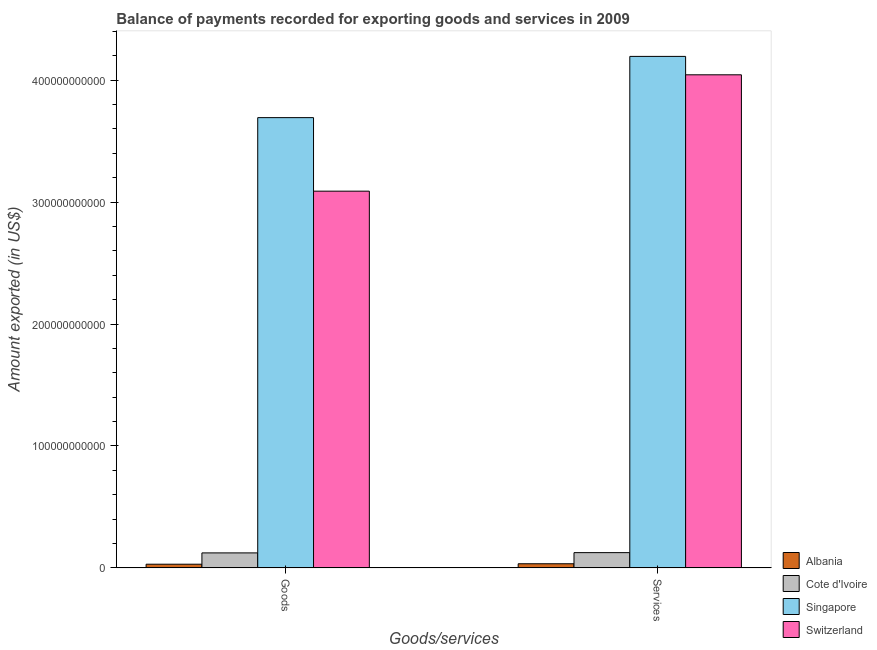How many different coloured bars are there?
Your response must be concise. 4. How many groups of bars are there?
Provide a short and direct response. 2. Are the number of bars per tick equal to the number of legend labels?
Your answer should be compact. Yes. How many bars are there on the 1st tick from the right?
Your answer should be very brief. 4. What is the label of the 2nd group of bars from the left?
Offer a very short reply. Services. What is the amount of goods exported in Albania?
Offer a terse response. 3.06e+09. Across all countries, what is the maximum amount of services exported?
Provide a short and direct response. 4.19e+11. Across all countries, what is the minimum amount of services exported?
Provide a short and direct response. 3.44e+09. In which country was the amount of services exported maximum?
Ensure brevity in your answer.  Singapore. In which country was the amount of services exported minimum?
Your response must be concise. Albania. What is the total amount of services exported in the graph?
Provide a succinct answer. 8.40e+11. What is the difference between the amount of services exported in Albania and that in Singapore?
Your answer should be compact. -4.16e+11. What is the difference between the amount of goods exported in Switzerland and the amount of services exported in Albania?
Ensure brevity in your answer.  3.05e+11. What is the average amount of services exported per country?
Provide a succinct answer. 2.10e+11. What is the difference between the amount of services exported and amount of goods exported in Albania?
Keep it short and to the point. 3.77e+08. What is the ratio of the amount of goods exported in Singapore to that in Cote d'Ivoire?
Your response must be concise. 29.92. Is the amount of goods exported in Albania less than that in Cote d'Ivoire?
Keep it short and to the point. Yes. In how many countries, is the amount of goods exported greater than the average amount of goods exported taken over all countries?
Offer a very short reply. 2. What does the 3rd bar from the left in Goods represents?
Offer a very short reply. Singapore. What does the 2nd bar from the right in Services represents?
Your response must be concise. Singapore. How many bars are there?
Give a very brief answer. 8. What is the difference between two consecutive major ticks on the Y-axis?
Keep it short and to the point. 1.00e+11. Are the values on the major ticks of Y-axis written in scientific E-notation?
Keep it short and to the point. No. Does the graph contain any zero values?
Make the answer very short. No. Does the graph contain grids?
Provide a succinct answer. No. Where does the legend appear in the graph?
Make the answer very short. Bottom right. How are the legend labels stacked?
Your answer should be compact. Vertical. What is the title of the graph?
Ensure brevity in your answer.  Balance of payments recorded for exporting goods and services in 2009. Does "Oman" appear as one of the legend labels in the graph?
Your answer should be compact. No. What is the label or title of the X-axis?
Your answer should be very brief. Goods/services. What is the label or title of the Y-axis?
Your answer should be compact. Amount exported (in US$). What is the Amount exported (in US$) of Albania in Goods?
Your answer should be compact. 3.06e+09. What is the Amount exported (in US$) of Cote d'Ivoire in Goods?
Keep it short and to the point. 1.23e+1. What is the Amount exported (in US$) in Singapore in Goods?
Make the answer very short. 3.69e+11. What is the Amount exported (in US$) of Switzerland in Goods?
Ensure brevity in your answer.  3.09e+11. What is the Amount exported (in US$) in Albania in Services?
Keep it short and to the point. 3.44e+09. What is the Amount exported (in US$) in Cote d'Ivoire in Services?
Offer a terse response. 1.26e+1. What is the Amount exported (in US$) in Singapore in Services?
Keep it short and to the point. 4.19e+11. What is the Amount exported (in US$) in Switzerland in Services?
Make the answer very short. 4.04e+11. Across all Goods/services, what is the maximum Amount exported (in US$) in Albania?
Offer a very short reply. 3.44e+09. Across all Goods/services, what is the maximum Amount exported (in US$) in Cote d'Ivoire?
Ensure brevity in your answer.  1.26e+1. Across all Goods/services, what is the maximum Amount exported (in US$) in Singapore?
Provide a short and direct response. 4.19e+11. Across all Goods/services, what is the maximum Amount exported (in US$) of Switzerland?
Provide a succinct answer. 4.04e+11. Across all Goods/services, what is the minimum Amount exported (in US$) of Albania?
Ensure brevity in your answer.  3.06e+09. Across all Goods/services, what is the minimum Amount exported (in US$) in Cote d'Ivoire?
Keep it short and to the point. 1.23e+1. Across all Goods/services, what is the minimum Amount exported (in US$) of Singapore?
Offer a very short reply. 3.69e+11. Across all Goods/services, what is the minimum Amount exported (in US$) of Switzerland?
Your answer should be very brief. 3.09e+11. What is the total Amount exported (in US$) of Albania in the graph?
Offer a very short reply. 6.50e+09. What is the total Amount exported (in US$) in Cote d'Ivoire in the graph?
Offer a very short reply. 2.49e+1. What is the total Amount exported (in US$) of Singapore in the graph?
Make the answer very short. 7.89e+11. What is the total Amount exported (in US$) of Switzerland in the graph?
Your answer should be very brief. 7.13e+11. What is the difference between the Amount exported (in US$) of Albania in Goods and that in Services?
Your answer should be compact. -3.77e+08. What is the difference between the Amount exported (in US$) in Cote d'Ivoire in Goods and that in Services?
Provide a short and direct response. -2.22e+08. What is the difference between the Amount exported (in US$) in Singapore in Goods and that in Services?
Keep it short and to the point. -5.02e+1. What is the difference between the Amount exported (in US$) of Switzerland in Goods and that in Services?
Your response must be concise. -9.54e+1. What is the difference between the Amount exported (in US$) in Albania in Goods and the Amount exported (in US$) in Cote d'Ivoire in Services?
Ensure brevity in your answer.  -9.50e+09. What is the difference between the Amount exported (in US$) of Albania in Goods and the Amount exported (in US$) of Singapore in Services?
Your answer should be compact. -4.16e+11. What is the difference between the Amount exported (in US$) of Albania in Goods and the Amount exported (in US$) of Switzerland in Services?
Your answer should be very brief. -4.01e+11. What is the difference between the Amount exported (in US$) in Cote d'Ivoire in Goods and the Amount exported (in US$) in Singapore in Services?
Offer a very short reply. -4.07e+11. What is the difference between the Amount exported (in US$) of Cote d'Ivoire in Goods and the Amount exported (in US$) of Switzerland in Services?
Offer a very short reply. -3.92e+11. What is the difference between the Amount exported (in US$) of Singapore in Goods and the Amount exported (in US$) of Switzerland in Services?
Provide a short and direct response. -3.51e+1. What is the average Amount exported (in US$) in Albania per Goods/services?
Your answer should be very brief. 3.25e+09. What is the average Amount exported (in US$) of Cote d'Ivoire per Goods/services?
Provide a succinct answer. 1.25e+1. What is the average Amount exported (in US$) of Singapore per Goods/services?
Your answer should be very brief. 3.94e+11. What is the average Amount exported (in US$) in Switzerland per Goods/services?
Make the answer very short. 3.57e+11. What is the difference between the Amount exported (in US$) in Albania and Amount exported (in US$) in Cote d'Ivoire in Goods?
Your answer should be very brief. -9.28e+09. What is the difference between the Amount exported (in US$) of Albania and Amount exported (in US$) of Singapore in Goods?
Give a very brief answer. -3.66e+11. What is the difference between the Amount exported (in US$) in Albania and Amount exported (in US$) in Switzerland in Goods?
Your answer should be compact. -3.06e+11. What is the difference between the Amount exported (in US$) in Cote d'Ivoire and Amount exported (in US$) in Singapore in Goods?
Your answer should be compact. -3.57e+11. What is the difference between the Amount exported (in US$) of Cote d'Ivoire and Amount exported (in US$) of Switzerland in Goods?
Your response must be concise. -2.97e+11. What is the difference between the Amount exported (in US$) in Singapore and Amount exported (in US$) in Switzerland in Goods?
Your response must be concise. 6.03e+1. What is the difference between the Amount exported (in US$) in Albania and Amount exported (in US$) in Cote d'Ivoire in Services?
Offer a very short reply. -9.12e+09. What is the difference between the Amount exported (in US$) in Albania and Amount exported (in US$) in Singapore in Services?
Keep it short and to the point. -4.16e+11. What is the difference between the Amount exported (in US$) in Albania and Amount exported (in US$) in Switzerland in Services?
Offer a very short reply. -4.01e+11. What is the difference between the Amount exported (in US$) in Cote d'Ivoire and Amount exported (in US$) in Singapore in Services?
Your answer should be very brief. -4.07e+11. What is the difference between the Amount exported (in US$) in Cote d'Ivoire and Amount exported (in US$) in Switzerland in Services?
Offer a terse response. -3.92e+11. What is the difference between the Amount exported (in US$) in Singapore and Amount exported (in US$) in Switzerland in Services?
Provide a short and direct response. 1.51e+1. What is the ratio of the Amount exported (in US$) in Albania in Goods to that in Services?
Keep it short and to the point. 0.89. What is the ratio of the Amount exported (in US$) of Cote d'Ivoire in Goods to that in Services?
Offer a very short reply. 0.98. What is the ratio of the Amount exported (in US$) of Singapore in Goods to that in Services?
Make the answer very short. 0.88. What is the ratio of the Amount exported (in US$) in Switzerland in Goods to that in Services?
Your response must be concise. 0.76. What is the difference between the highest and the second highest Amount exported (in US$) of Albania?
Give a very brief answer. 3.77e+08. What is the difference between the highest and the second highest Amount exported (in US$) of Cote d'Ivoire?
Ensure brevity in your answer.  2.22e+08. What is the difference between the highest and the second highest Amount exported (in US$) in Singapore?
Provide a succinct answer. 5.02e+1. What is the difference between the highest and the second highest Amount exported (in US$) of Switzerland?
Offer a terse response. 9.54e+1. What is the difference between the highest and the lowest Amount exported (in US$) of Albania?
Your response must be concise. 3.77e+08. What is the difference between the highest and the lowest Amount exported (in US$) of Cote d'Ivoire?
Provide a short and direct response. 2.22e+08. What is the difference between the highest and the lowest Amount exported (in US$) in Singapore?
Offer a terse response. 5.02e+1. What is the difference between the highest and the lowest Amount exported (in US$) in Switzerland?
Your answer should be very brief. 9.54e+1. 